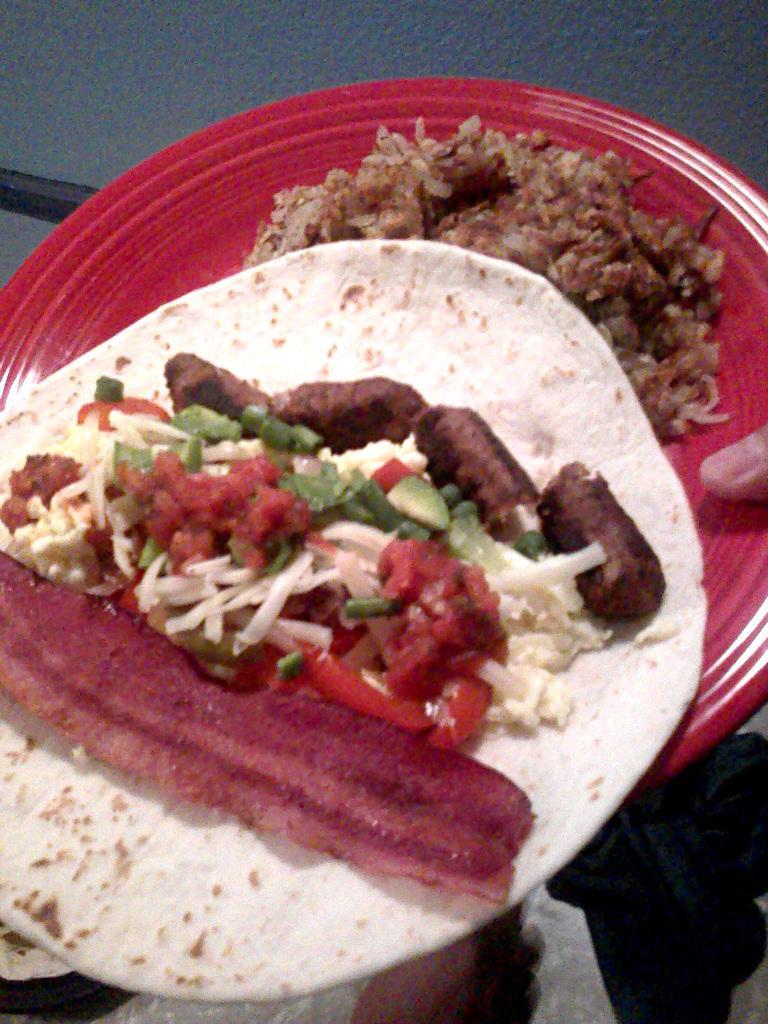Could you give a brief overview of what you see in this image? In the picture I can see the hand of a person holding a red color plate. I can see the rice on the plate and a Chapati with curry on it. 